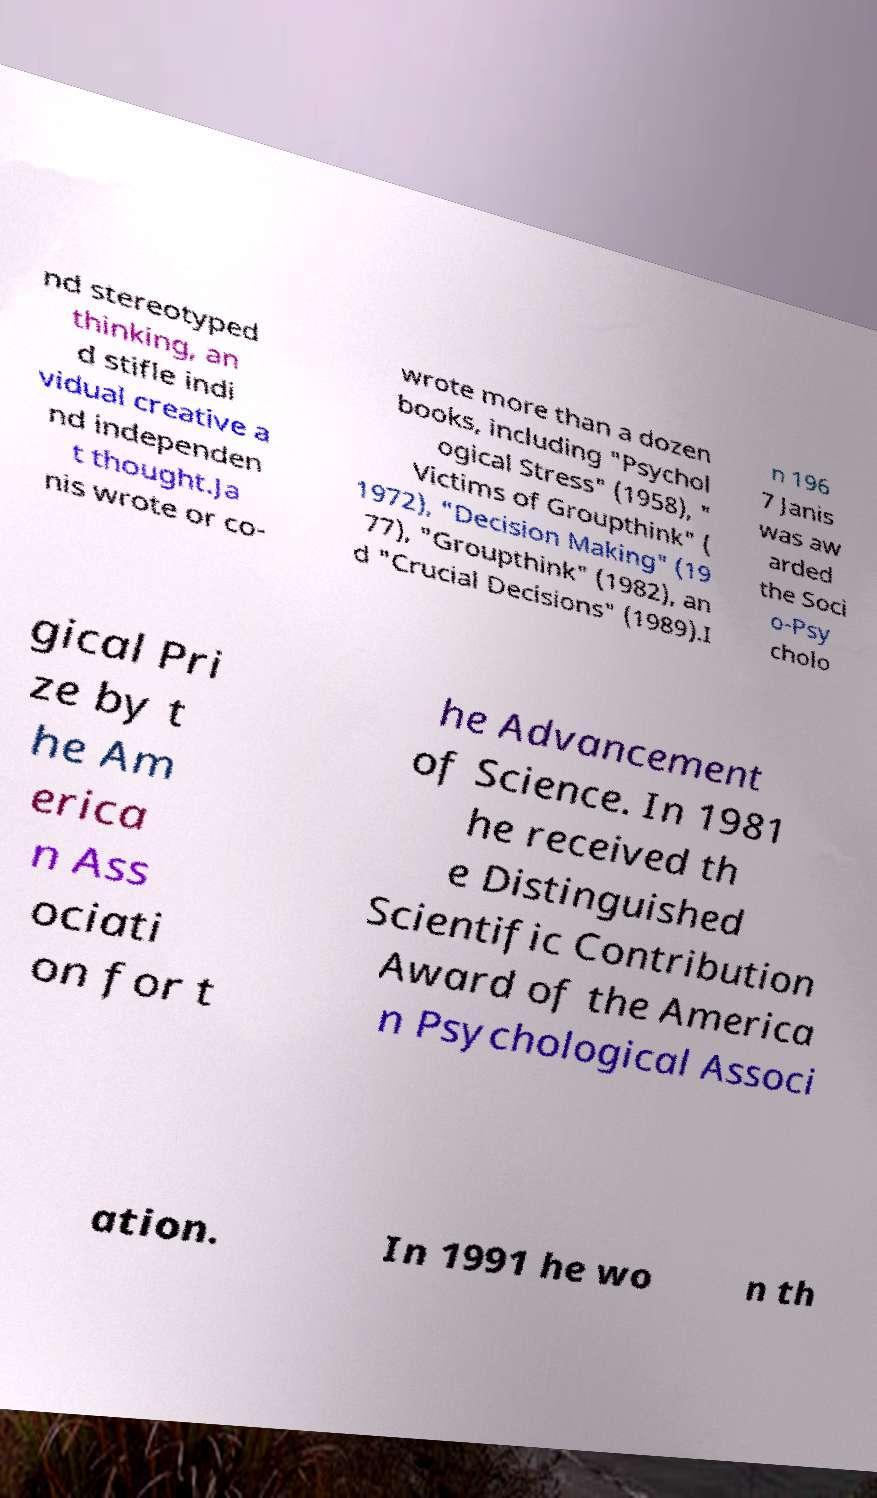Please read and relay the text visible in this image. What does it say? nd stereotyped thinking, an d stifle indi vidual creative a nd independen t thought.Ja nis wrote or co- wrote more than a dozen books, including "Psychol ogical Stress" (1958), " Victims of Groupthink" ( 1972), "Decision Making" (19 77), "Groupthink" (1982), an d "Crucial Decisions" (1989).I n 196 7 Janis was aw arded the Soci o-Psy cholo gical Pri ze by t he Am erica n Ass ociati on for t he Advancement of Science. In 1981 he received th e Distinguished Scientific Contribution Award of the America n Psychological Associ ation. In 1991 he wo n th 